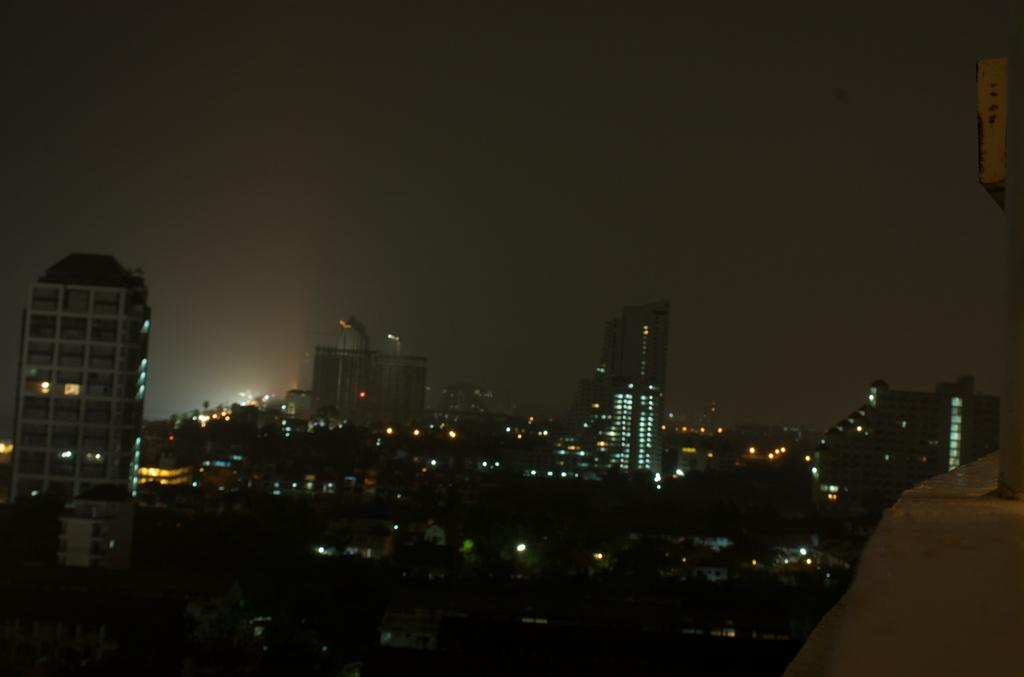What is the time of day depicted in the image? The image is taken in the dark, which suggests it is nighttime. What type of location is shown in the image? The image depicts a city at night. What features of the buildings are visible in the image? There are buildings with lights in the image. What can be seen in the sky in the image? The sky is visible at the top of the image. What is the value of the arch in the image? There is no arch present in the image, so it is not possible to determine its value. 